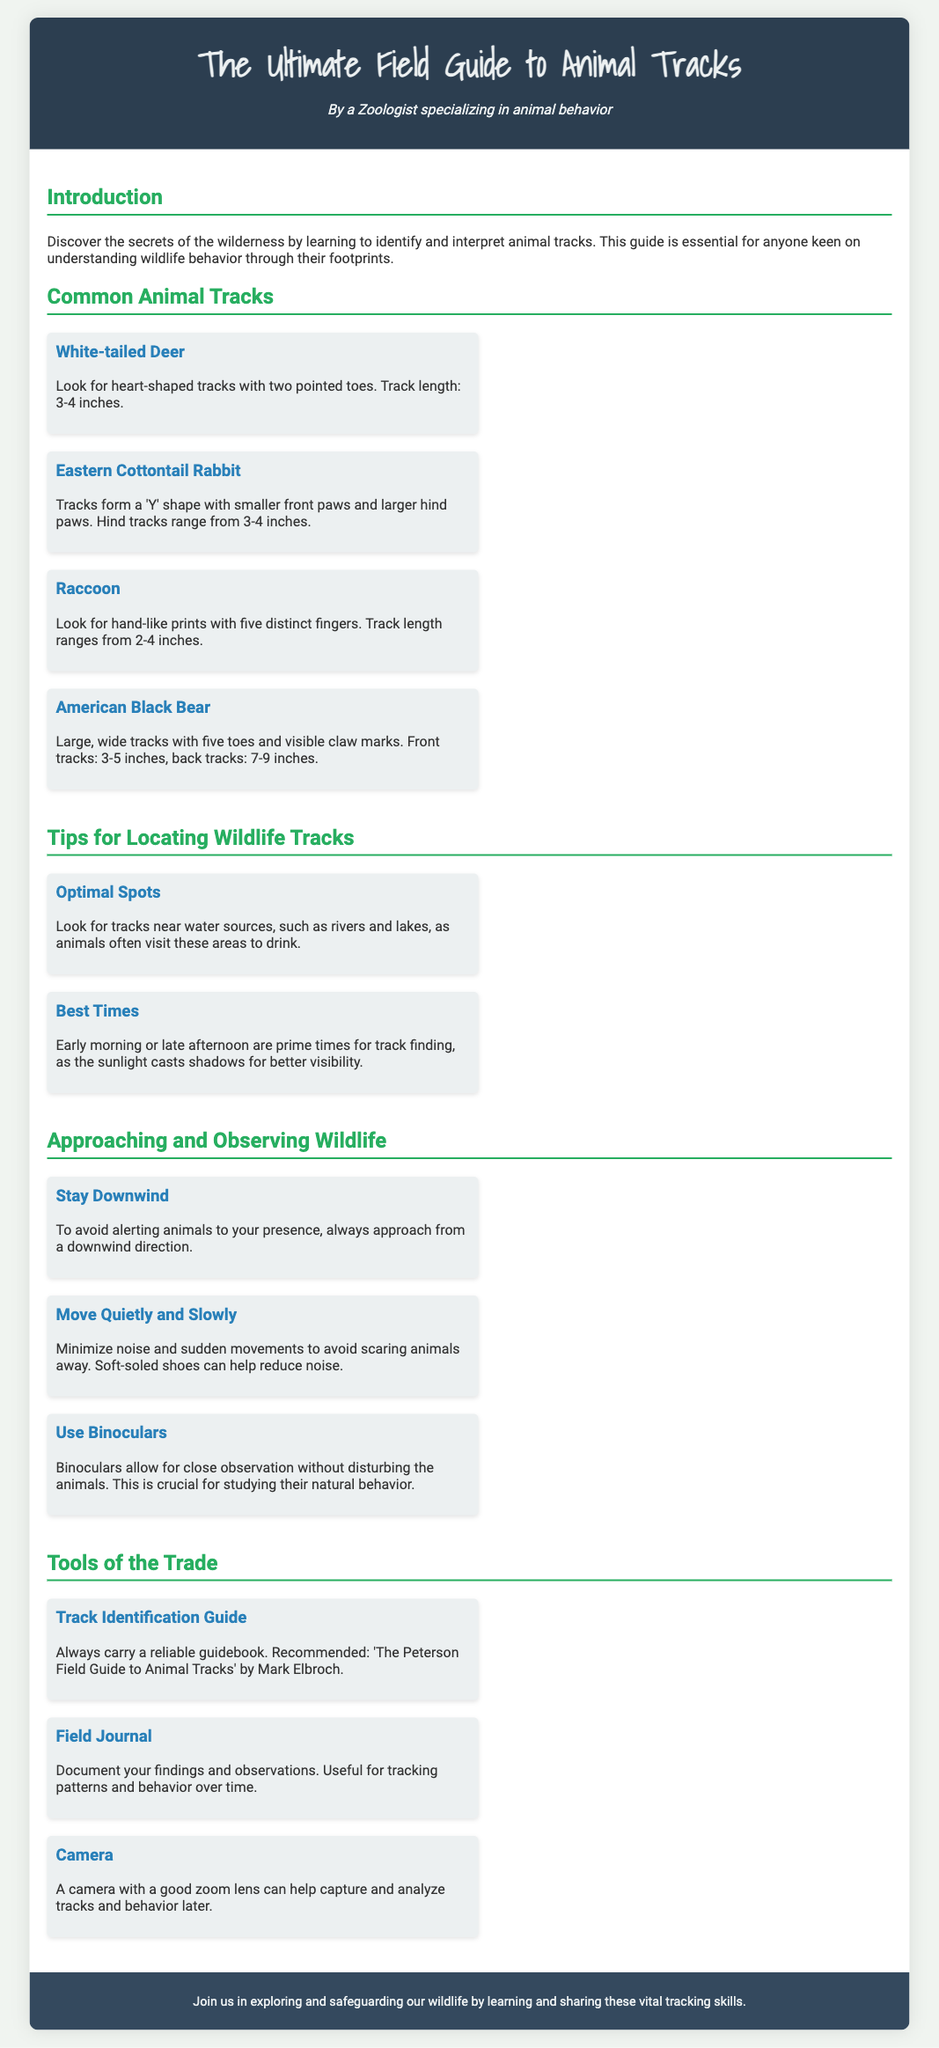What type of guide is this? The title of the document explicitly states that it is a field guide to animal tracks.
Answer: Field Guide How many inches are the front tracks of an American Black Bear? The document specifies that the front tracks of an American Black Bear range from 3-5 inches.
Answer: 3-5 inches What shape do Eastern Cottontail Rabbit tracks form? The document describes the tracks of an Eastern Cottontail Rabbit as forming a 'Y' shape.
Answer: 'Y' shape What time of day is best for finding tracks? The document recommends early morning or late afternoon as prime times for track finding.
Answer: Early morning or late afternoon What is one tool recommended for identifying tracks? The document suggests carrying a reliable guidebook for track identification.
Answer: Track Identification Guide What should you do to avoid alerting animals? The document instructs to approach from a downwind direction to avoid alerting animals.
Answer: Stay Downwind What is essential for documenting observations? The document emphasizes the importance of having a field journal for documenting findings.
Answer: Field Journal What color are White-tailed Deer tracks? The document describes White-tailed Deer tracks as heart-shaped, but does not specify a color.
Answer: Heart-shaped What can binoculars help with in wildlife observation? The document states that binoculars allow for close observation without disturbing the animals.
Answer: Close observation without disturbing 